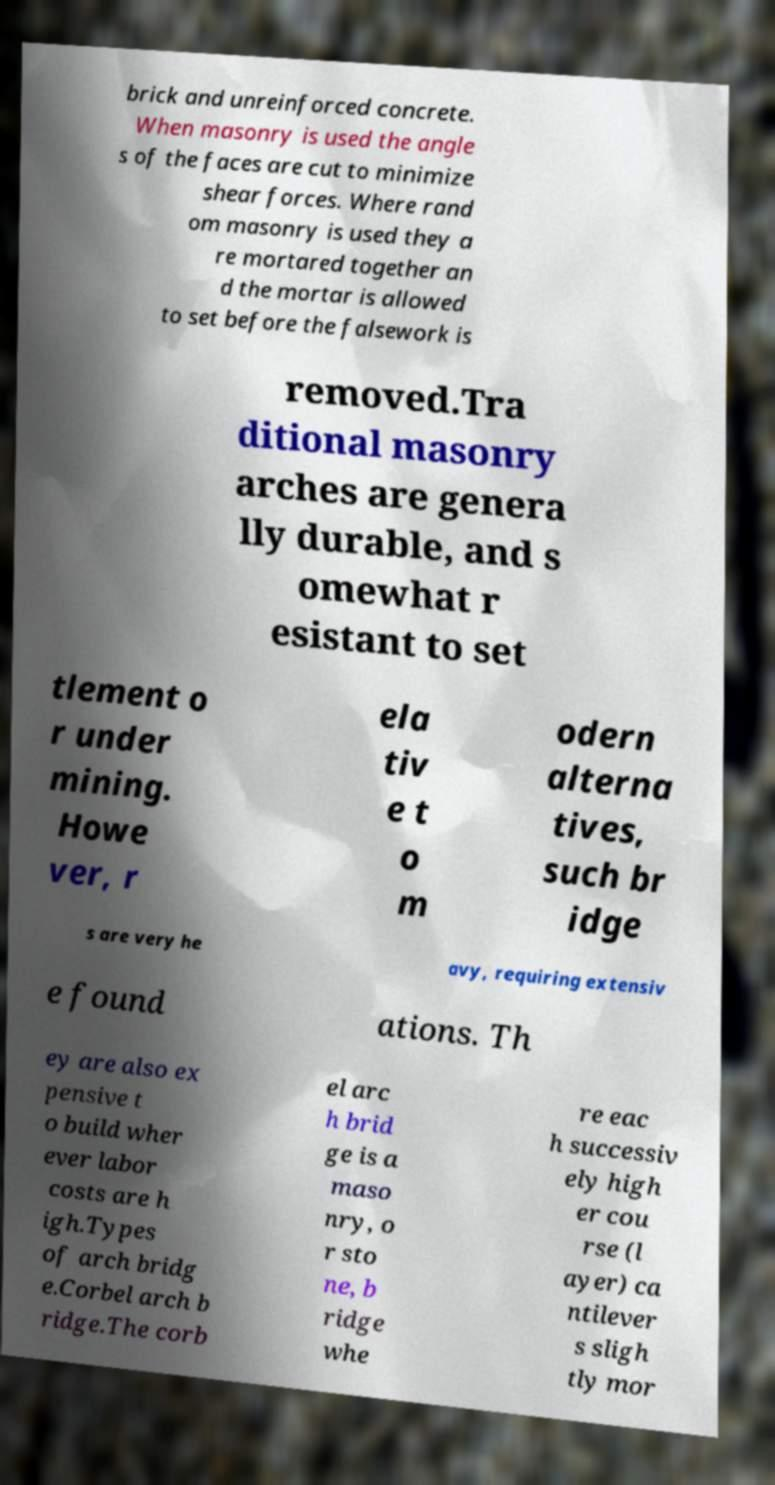Could you extract and type out the text from this image? brick and unreinforced concrete. When masonry is used the angle s of the faces are cut to minimize shear forces. Where rand om masonry is used they a re mortared together an d the mortar is allowed to set before the falsework is removed.Tra ditional masonry arches are genera lly durable, and s omewhat r esistant to set tlement o r under mining. Howe ver, r ela tiv e t o m odern alterna tives, such br idge s are very he avy, requiring extensiv e found ations. Th ey are also ex pensive t o build wher ever labor costs are h igh.Types of arch bridg e.Corbel arch b ridge.The corb el arc h brid ge is a maso nry, o r sto ne, b ridge whe re eac h successiv ely high er cou rse (l ayer) ca ntilever s sligh tly mor 